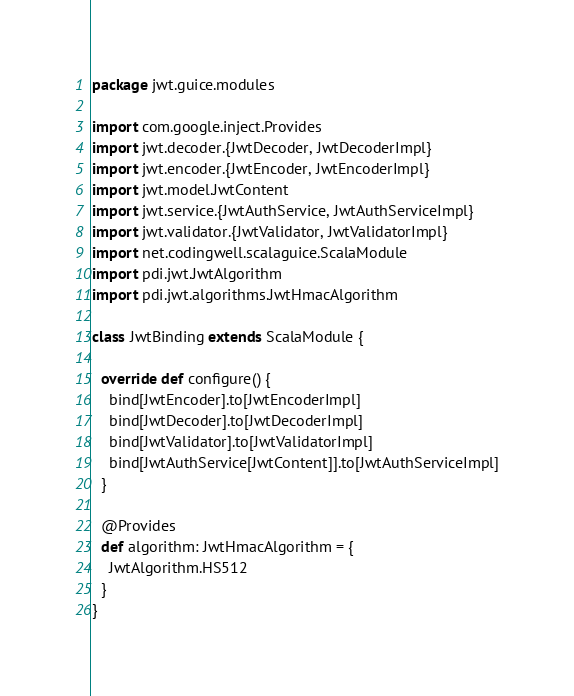<code> <loc_0><loc_0><loc_500><loc_500><_Scala_>package jwt.guice.modules

import com.google.inject.Provides
import jwt.decoder.{JwtDecoder, JwtDecoderImpl}
import jwt.encoder.{JwtEncoder, JwtEncoderImpl}
import jwt.model.JwtContent
import jwt.service.{JwtAuthService, JwtAuthServiceImpl}
import jwt.validator.{JwtValidator, JwtValidatorImpl}
import net.codingwell.scalaguice.ScalaModule
import pdi.jwt.JwtAlgorithm
import pdi.jwt.algorithms.JwtHmacAlgorithm

class JwtBinding extends ScalaModule {

  override def configure() {
    bind[JwtEncoder].to[JwtEncoderImpl]
    bind[JwtDecoder].to[JwtDecoderImpl]
    bind[JwtValidator].to[JwtValidatorImpl]
    bind[JwtAuthService[JwtContent]].to[JwtAuthServiceImpl]
  }

  @Provides
  def algorithm: JwtHmacAlgorithm = {
    JwtAlgorithm.HS512
  }
}
</code> 